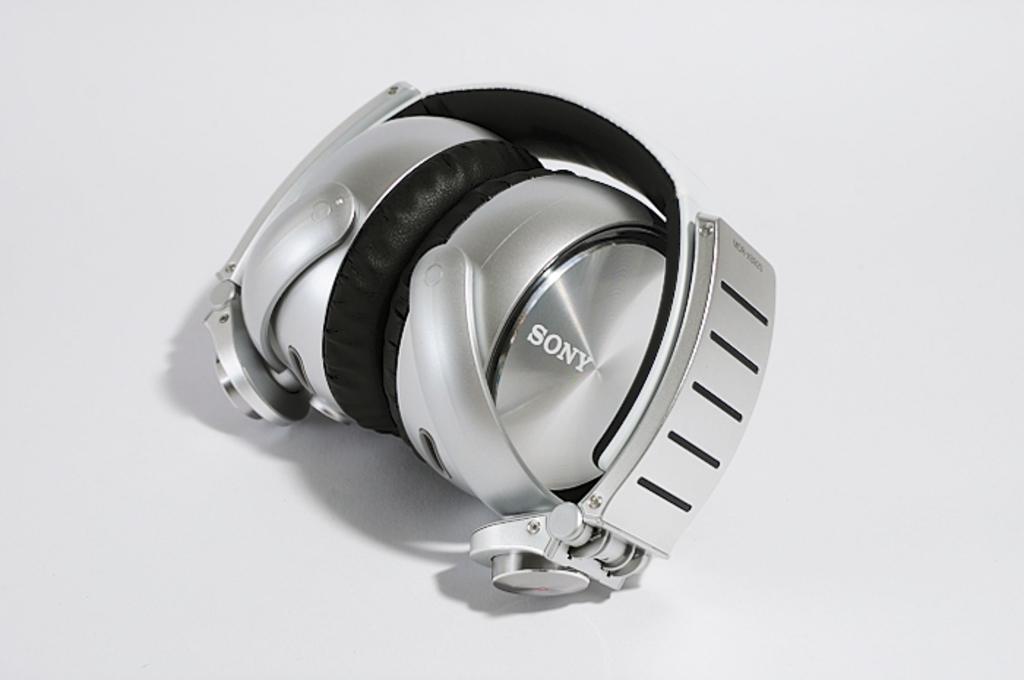What brand of watch is this?
Offer a terse response. Sony. First 2 letters of the brand name?
Your answer should be very brief. So. 